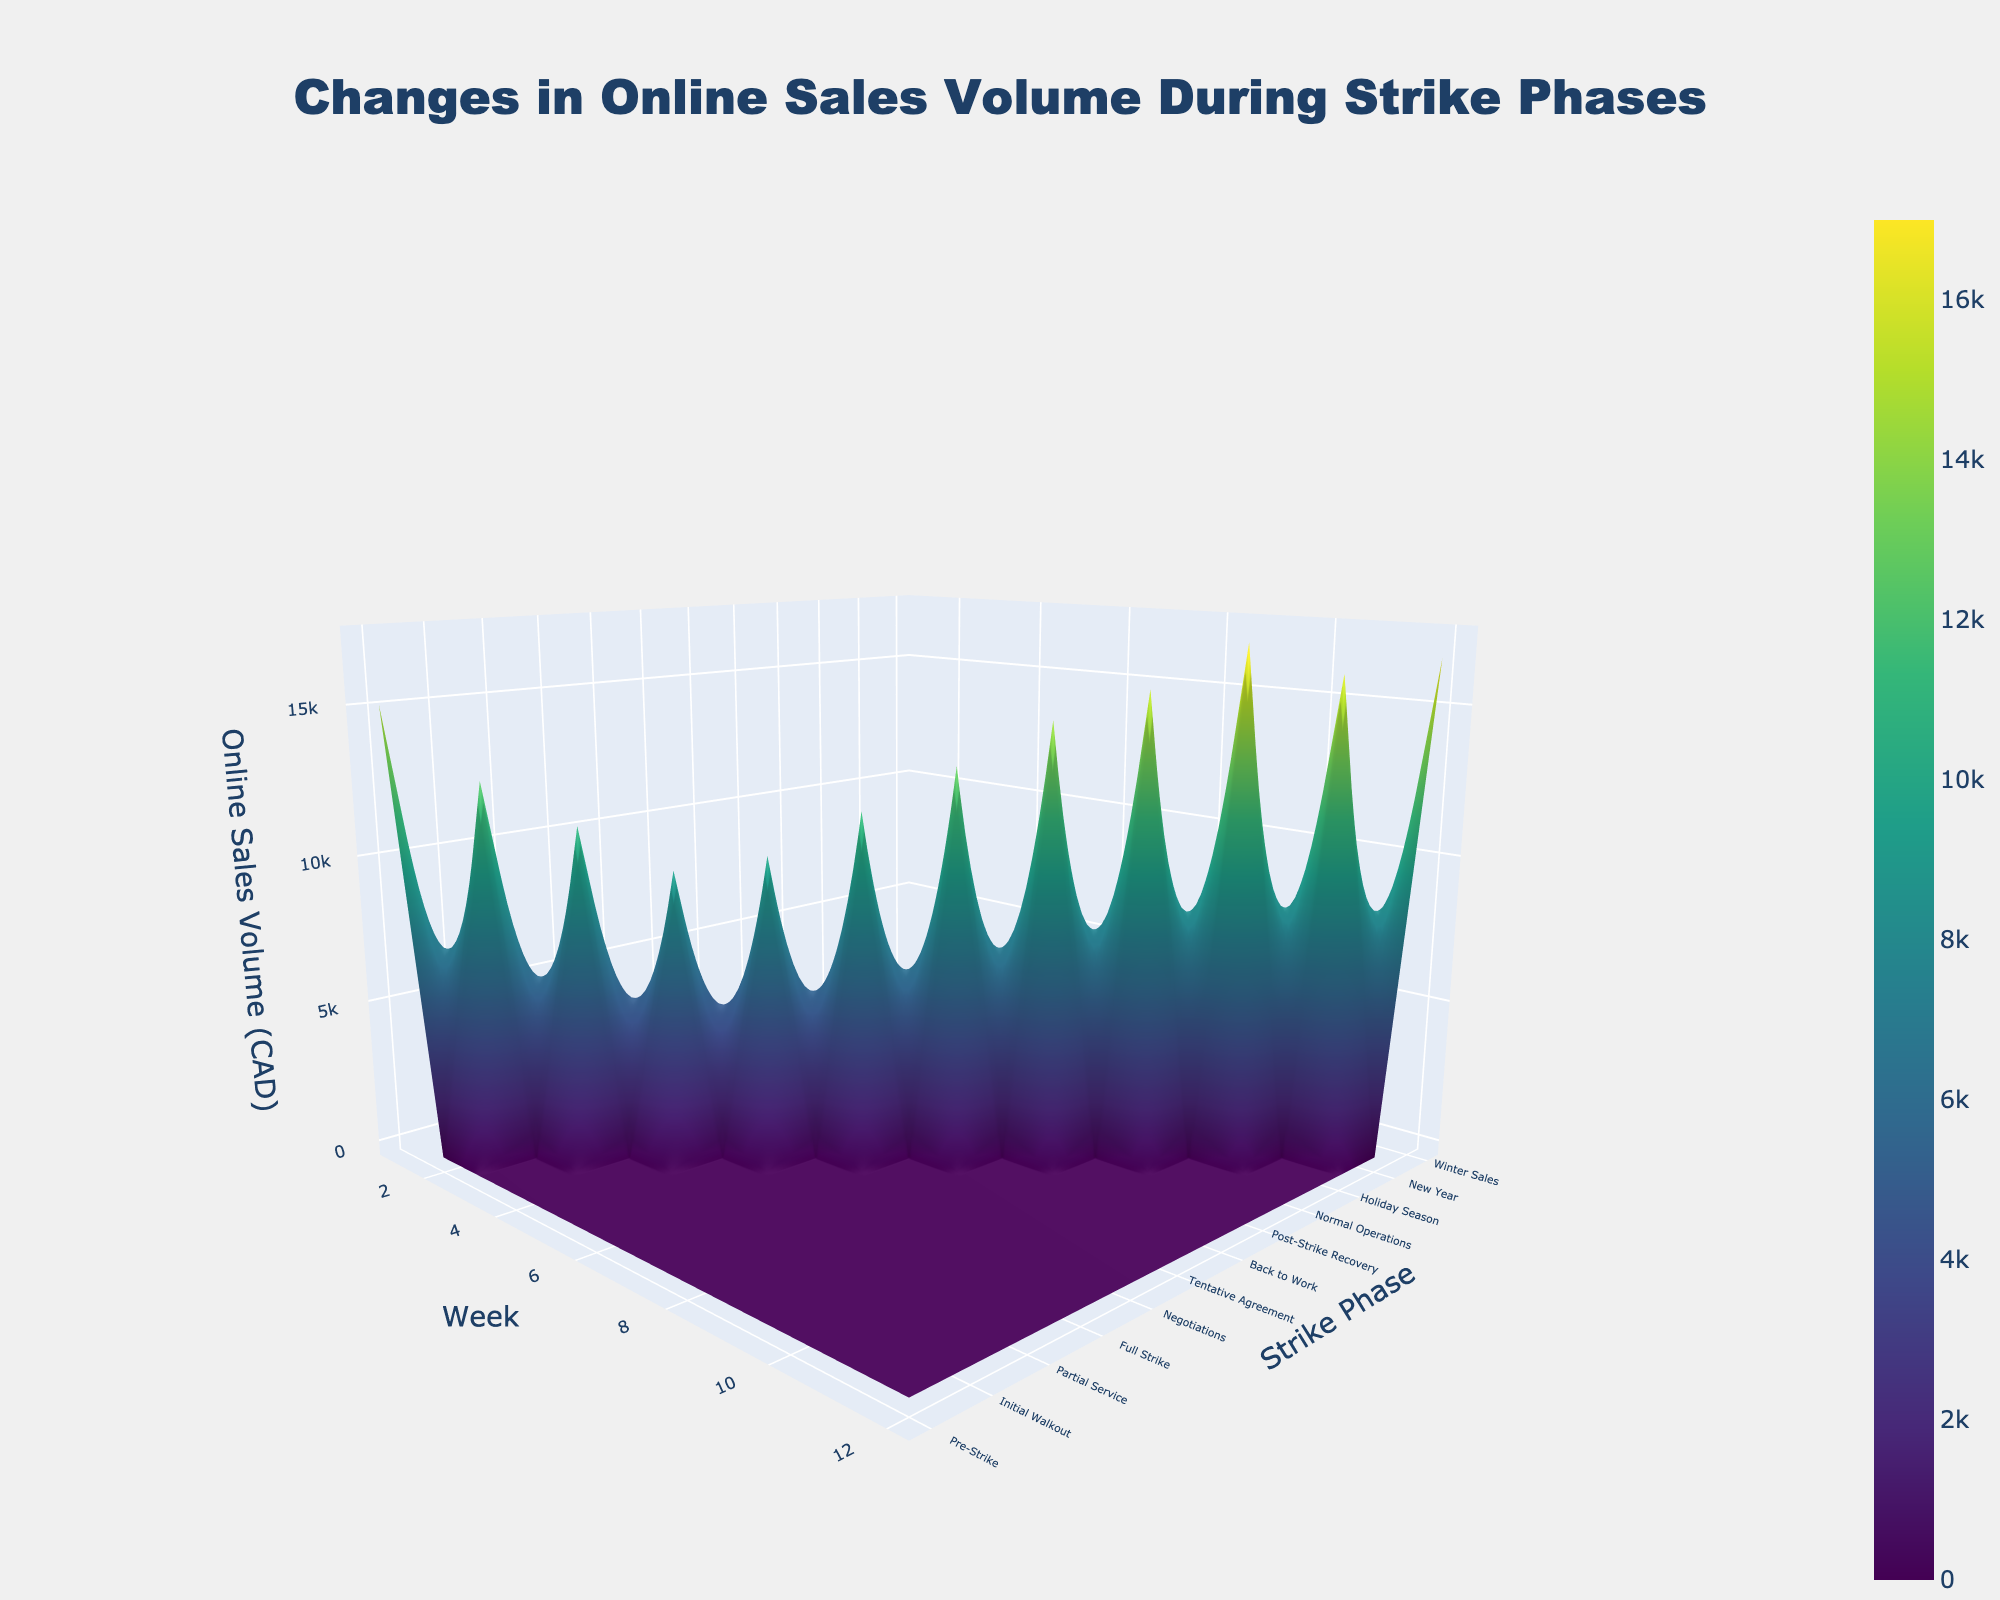What is the title of the 3D surface plot? The title is located at the top-center of the plot and can be read directly from there
Answer: Changes in Online Sales Volume During Strike Phases Which strike phase had the lowest online sales volume? By observing the z-axis values across different strike phases, the phase with the lowest z-axis value corresponds to the lowest online sales volume
Answer: Full Strike How does the online sales volume change from the 'Pre-Strike' to the 'Full Strike' phase? Compare the z-axis values at these phases; notice the trend from higher to lower values indicating a decline in sales
Answer: It decreases What is the trend in online sales volume during the 'Post-Strike Recovery' phase? Look at the z-axis value associated with the 'Post-Strike Recovery' phase; it shows an increasing trend towards recovery
Answer: Increasing What is the overall shape of the online sales volume throughout the strike phases? Observe the 3D surface plot overall; the shape initially dips and then rises, showing a V-like pattern
Answer: V-like pattern Which week shows the highest online sales volume? By comparing the z-axis values at each time point, the week with the highest z-axis value indicates the highest online sales volume
Answer: Holiday Season (Week 10) Is there a phase where the sales volume remains stable? Check if there is any part of the surface plot that shows constant z-axis values without any significant dips or peaks
Answer: No, the sales volume fluctuates How many distinct strike phases are represented in the plot? Count the distinct ticks along the y-axis labeled with strike phases
Answer: 8 What phase sees the greatest recovery in online sales volume? Find the phase where z-axis values significantly increase after a period of decline
Answer: Tentative Agreement By how much does the online sales volume increase from 'Negotiations' to 'Holiday Season'? Check the z-axis values at 'Negotiations' and 'Holiday Season', and then subtract the value at 'Negotiations' from that at 'Holiday Season'
Answer: $7,000 